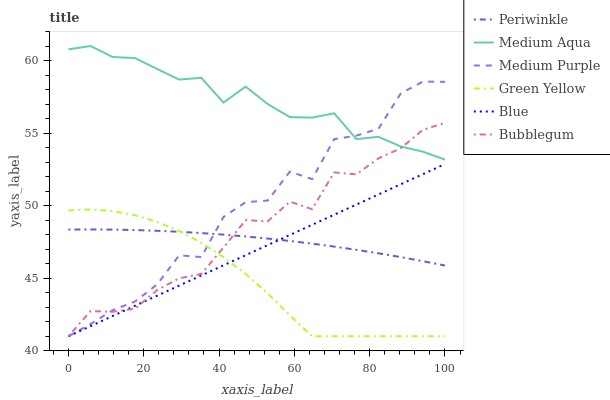Does Green Yellow have the minimum area under the curve?
Answer yes or no. Yes. Does Medium Aqua have the maximum area under the curve?
Answer yes or no. Yes. Does Bubblegum have the minimum area under the curve?
Answer yes or no. No. Does Bubblegum have the maximum area under the curve?
Answer yes or no. No. Is Blue the smoothest?
Answer yes or no. Yes. Is Medium Purple the roughest?
Answer yes or no. Yes. Is Bubblegum the smoothest?
Answer yes or no. No. Is Bubblegum the roughest?
Answer yes or no. No. Does Medium Aqua have the lowest value?
Answer yes or no. No. Does Medium Aqua have the highest value?
Answer yes or no. Yes. Does Bubblegum have the highest value?
Answer yes or no. No. Is Blue less than Medium Aqua?
Answer yes or no. Yes. Is Medium Aqua greater than Green Yellow?
Answer yes or no. Yes. Does Periwinkle intersect Medium Purple?
Answer yes or no. Yes. Is Periwinkle less than Medium Purple?
Answer yes or no. No. Is Periwinkle greater than Medium Purple?
Answer yes or no. No. Does Blue intersect Medium Aqua?
Answer yes or no. No. 